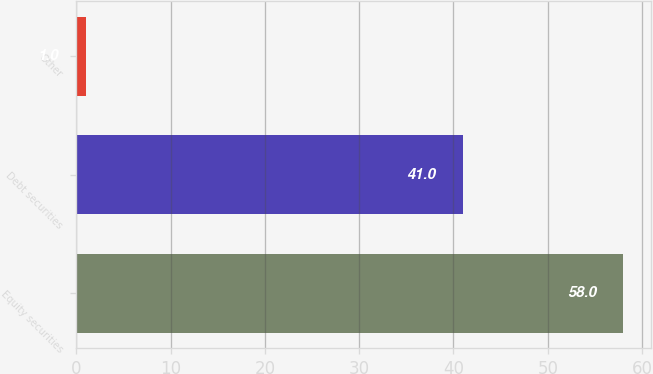Convert chart. <chart><loc_0><loc_0><loc_500><loc_500><bar_chart><fcel>Equity securities<fcel>Debt securities<fcel>Other<nl><fcel>58<fcel>41<fcel>1<nl></chart> 